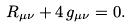Convert formula to latex. <formula><loc_0><loc_0><loc_500><loc_500>R _ { \mu \nu } + 4 \, g _ { \mu \nu } = 0 .</formula> 